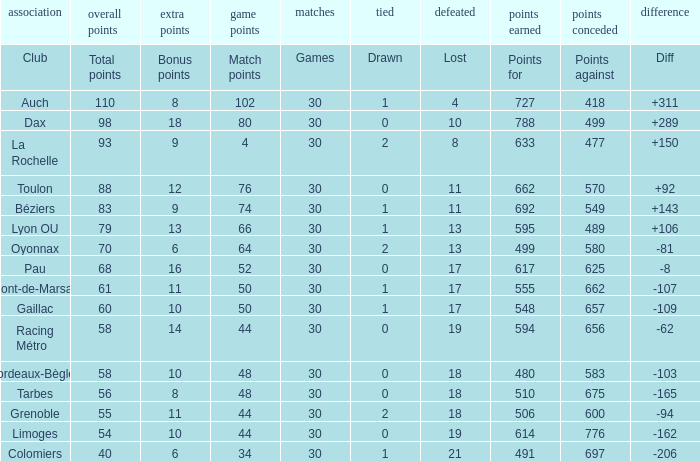What is the number of games for a club that has a value of 595 for points for? 30.0. 